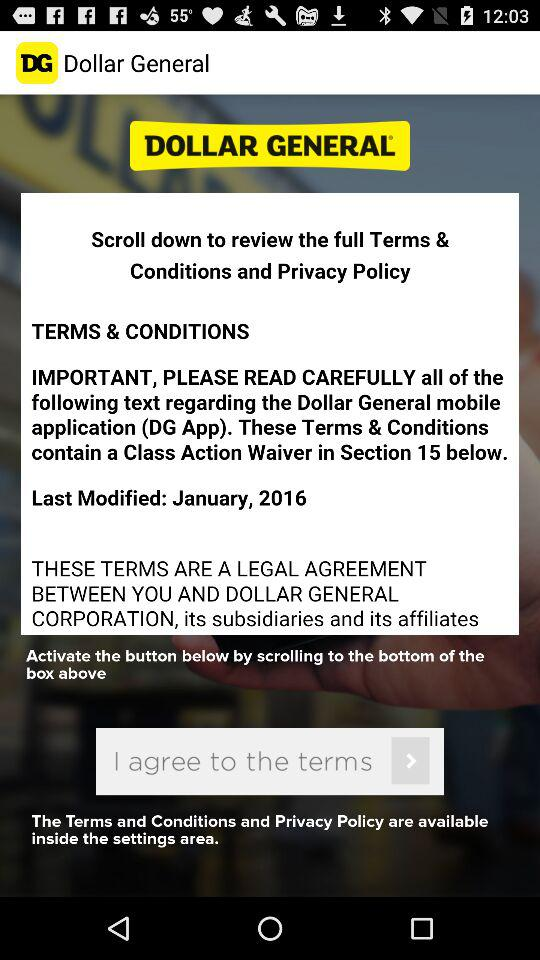What is the last modified date? The last modified date is January, 2016. 